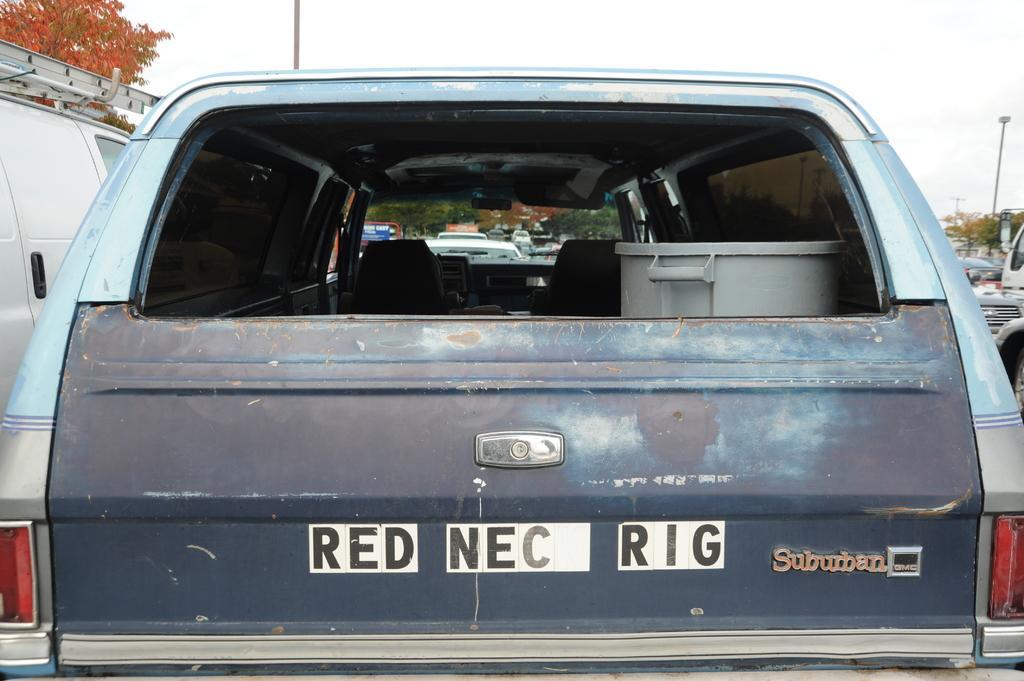Could you give a brief overview of what you see in this image? In this image, we can see a vehicle, seats and object. Here we can see few stickers on the vehicle. From the right side to the left of the image, we can see vehicle, trees and poles. Top of the image, there is a sky. 